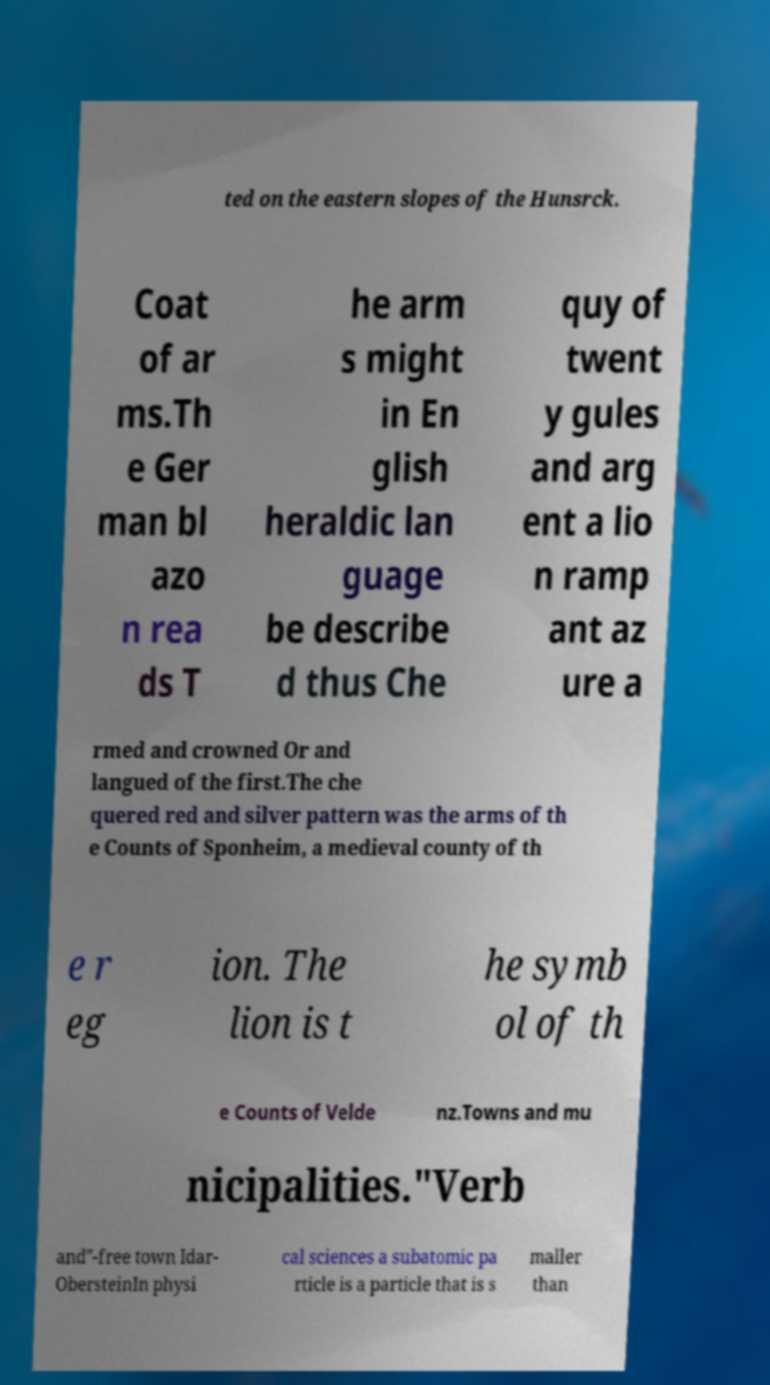Could you assist in decoding the text presented in this image and type it out clearly? ted on the eastern slopes of the Hunsrck. Coat of ar ms.Th e Ger man bl azo n rea ds T he arm s might in En glish heraldic lan guage be describe d thus Che quy of twent y gules and arg ent a lio n ramp ant az ure a rmed and crowned Or and langued of the first.The che quered red and silver pattern was the arms of th e Counts of Sponheim, a medieval county of th e r eg ion. The lion is t he symb ol of th e Counts of Velde nz.Towns and mu nicipalities."Verb and"-free town Idar- ObersteinIn physi cal sciences a subatomic pa rticle is a particle that is s maller than 